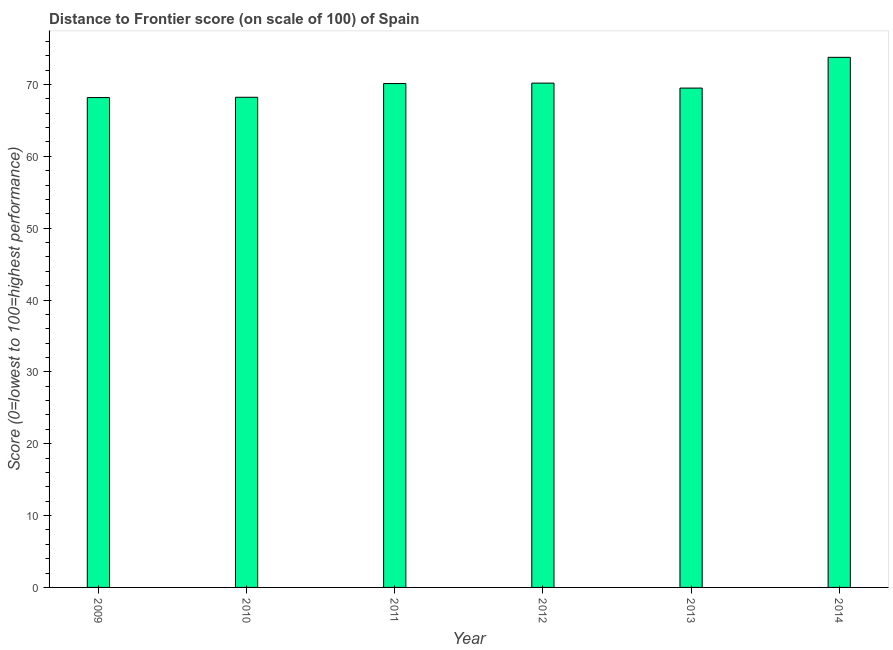Does the graph contain any zero values?
Offer a terse response. No. What is the title of the graph?
Make the answer very short. Distance to Frontier score (on scale of 100) of Spain. What is the label or title of the Y-axis?
Your response must be concise. Score (0=lowest to 100=highest performance). What is the distance to frontier score in 2010?
Keep it short and to the point. 68.22. Across all years, what is the maximum distance to frontier score?
Offer a very short reply. 73.78. Across all years, what is the minimum distance to frontier score?
Provide a short and direct response. 68.18. In which year was the distance to frontier score minimum?
Your answer should be very brief. 2009. What is the sum of the distance to frontier score?
Offer a terse response. 420. What is the difference between the distance to frontier score in 2009 and 2012?
Provide a succinct answer. -2.01. What is the average distance to frontier score per year?
Keep it short and to the point. 70. What is the median distance to frontier score?
Offer a very short reply. 69.81. In how many years, is the distance to frontier score greater than 42 ?
Make the answer very short. 6. What is the ratio of the distance to frontier score in 2013 to that in 2014?
Your answer should be very brief. 0.94. Is the distance to frontier score in 2009 less than that in 2010?
Make the answer very short. Yes. What is the difference between the highest and the second highest distance to frontier score?
Your answer should be compact. 3.59. In how many years, is the distance to frontier score greater than the average distance to frontier score taken over all years?
Your answer should be compact. 3. How many bars are there?
Provide a succinct answer. 6. Are all the bars in the graph horizontal?
Your answer should be compact. No. How many years are there in the graph?
Provide a short and direct response. 6. Are the values on the major ticks of Y-axis written in scientific E-notation?
Provide a succinct answer. No. What is the Score (0=lowest to 100=highest performance) in 2009?
Your answer should be compact. 68.18. What is the Score (0=lowest to 100=highest performance) of 2010?
Ensure brevity in your answer.  68.22. What is the Score (0=lowest to 100=highest performance) in 2011?
Give a very brief answer. 70.13. What is the Score (0=lowest to 100=highest performance) in 2012?
Make the answer very short. 70.19. What is the Score (0=lowest to 100=highest performance) in 2013?
Provide a succinct answer. 69.5. What is the Score (0=lowest to 100=highest performance) of 2014?
Your response must be concise. 73.78. What is the difference between the Score (0=lowest to 100=highest performance) in 2009 and 2010?
Offer a terse response. -0.04. What is the difference between the Score (0=lowest to 100=highest performance) in 2009 and 2011?
Offer a terse response. -1.95. What is the difference between the Score (0=lowest to 100=highest performance) in 2009 and 2012?
Your answer should be compact. -2.01. What is the difference between the Score (0=lowest to 100=highest performance) in 2009 and 2013?
Ensure brevity in your answer.  -1.32. What is the difference between the Score (0=lowest to 100=highest performance) in 2009 and 2014?
Make the answer very short. -5.6. What is the difference between the Score (0=lowest to 100=highest performance) in 2010 and 2011?
Your response must be concise. -1.91. What is the difference between the Score (0=lowest to 100=highest performance) in 2010 and 2012?
Your response must be concise. -1.97. What is the difference between the Score (0=lowest to 100=highest performance) in 2010 and 2013?
Ensure brevity in your answer.  -1.28. What is the difference between the Score (0=lowest to 100=highest performance) in 2010 and 2014?
Provide a succinct answer. -5.56. What is the difference between the Score (0=lowest to 100=highest performance) in 2011 and 2012?
Make the answer very short. -0.06. What is the difference between the Score (0=lowest to 100=highest performance) in 2011 and 2013?
Your answer should be compact. 0.63. What is the difference between the Score (0=lowest to 100=highest performance) in 2011 and 2014?
Ensure brevity in your answer.  -3.65. What is the difference between the Score (0=lowest to 100=highest performance) in 2012 and 2013?
Keep it short and to the point. 0.69. What is the difference between the Score (0=lowest to 100=highest performance) in 2012 and 2014?
Ensure brevity in your answer.  -3.59. What is the difference between the Score (0=lowest to 100=highest performance) in 2013 and 2014?
Give a very brief answer. -4.28. What is the ratio of the Score (0=lowest to 100=highest performance) in 2009 to that in 2010?
Provide a short and direct response. 1. What is the ratio of the Score (0=lowest to 100=highest performance) in 2009 to that in 2011?
Offer a terse response. 0.97. What is the ratio of the Score (0=lowest to 100=highest performance) in 2009 to that in 2013?
Offer a terse response. 0.98. What is the ratio of the Score (0=lowest to 100=highest performance) in 2009 to that in 2014?
Your response must be concise. 0.92. What is the ratio of the Score (0=lowest to 100=highest performance) in 2010 to that in 2011?
Provide a short and direct response. 0.97. What is the ratio of the Score (0=lowest to 100=highest performance) in 2010 to that in 2012?
Offer a terse response. 0.97. What is the ratio of the Score (0=lowest to 100=highest performance) in 2010 to that in 2013?
Make the answer very short. 0.98. What is the ratio of the Score (0=lowest to 100=highest performance) in 2010 to that in 2014?
Provide a succinct answer. 0.93. What is the ratio of the Score (0=lowest to 100=highest performance) in 2011 to that in 2013?
Provide a succinct answer. 1.01. What is the ratio of the Score (0=lowest to 100=highest performance) in 2011 to that in 2014?
Your answer should be compact. 0.95. What is the ratio of the Score (0=lowest to 100=highest performance) in 2012 to that in 2013?
Offer a very short reply. 1.01. What is the ratio of the Score (0=lowest to 100=highest performance) in 2012 to that in 2014?
Your answer should be very brief. 0.95. What is the ratio of the Score (0=lowest to 100=highest performance) in 2013 to that in 2014?
Your answer should be compact. 0.94. 